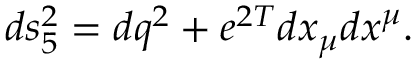<formula> <loc_0><loc_0><loc_500><loc_500>d s _ { 5 } ^ { 2 } = d q ^ { 2 } + e ^ { 2 T } d x _ { \mu } d x ^ { \mu } .</formula> 